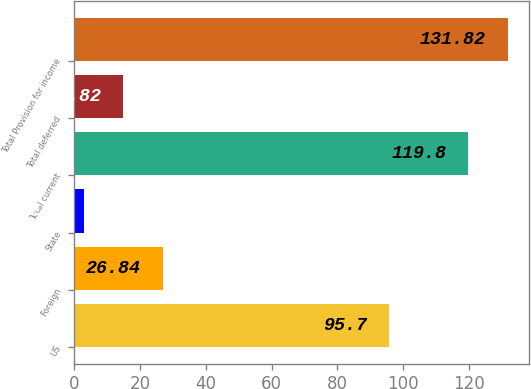<chart> <loc_0><loc_0><loc_500><loc_500><bar_chart><fcel>US<fcel>Foreign<fcel>State<fcel>Total current<fcel>Total deferred<fcel>Total Provision for income<nl><fcel>95.7<fcel>26.84<fcel>2.8<fcel>119.8<fcel>14.82<fcel>131.82<nl></chart> 